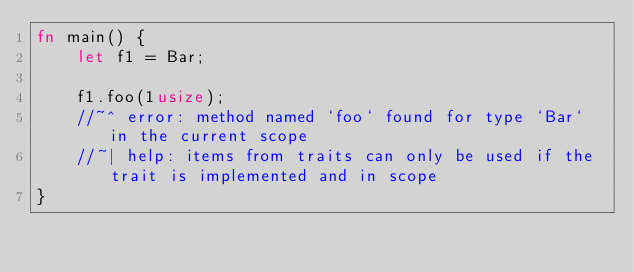<code> <loc_0><loc_0><loc_500><loc_500><_Rust_>fn main() {
    let f1 = Bar;

    f1.foo(1usize);
    //~^ error: method named `foo` found for type `Bar` in the current scope
    //~| help: items from traits can only be used if the trait is implemented and in scope
}
</code> 